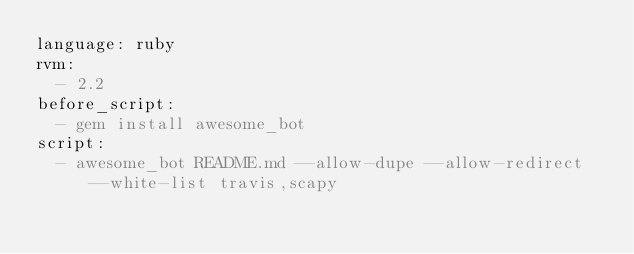<code> <loc_0><loc_0><loc_500><loc_500><_YAML_>language: ruby
rvm:
  - 2.2
before_script:
  - gem install awesome_bot
script:
  - awesome_bot README.md --allow-dupe --allow-redirect --white-list travis,scapy
</code> 